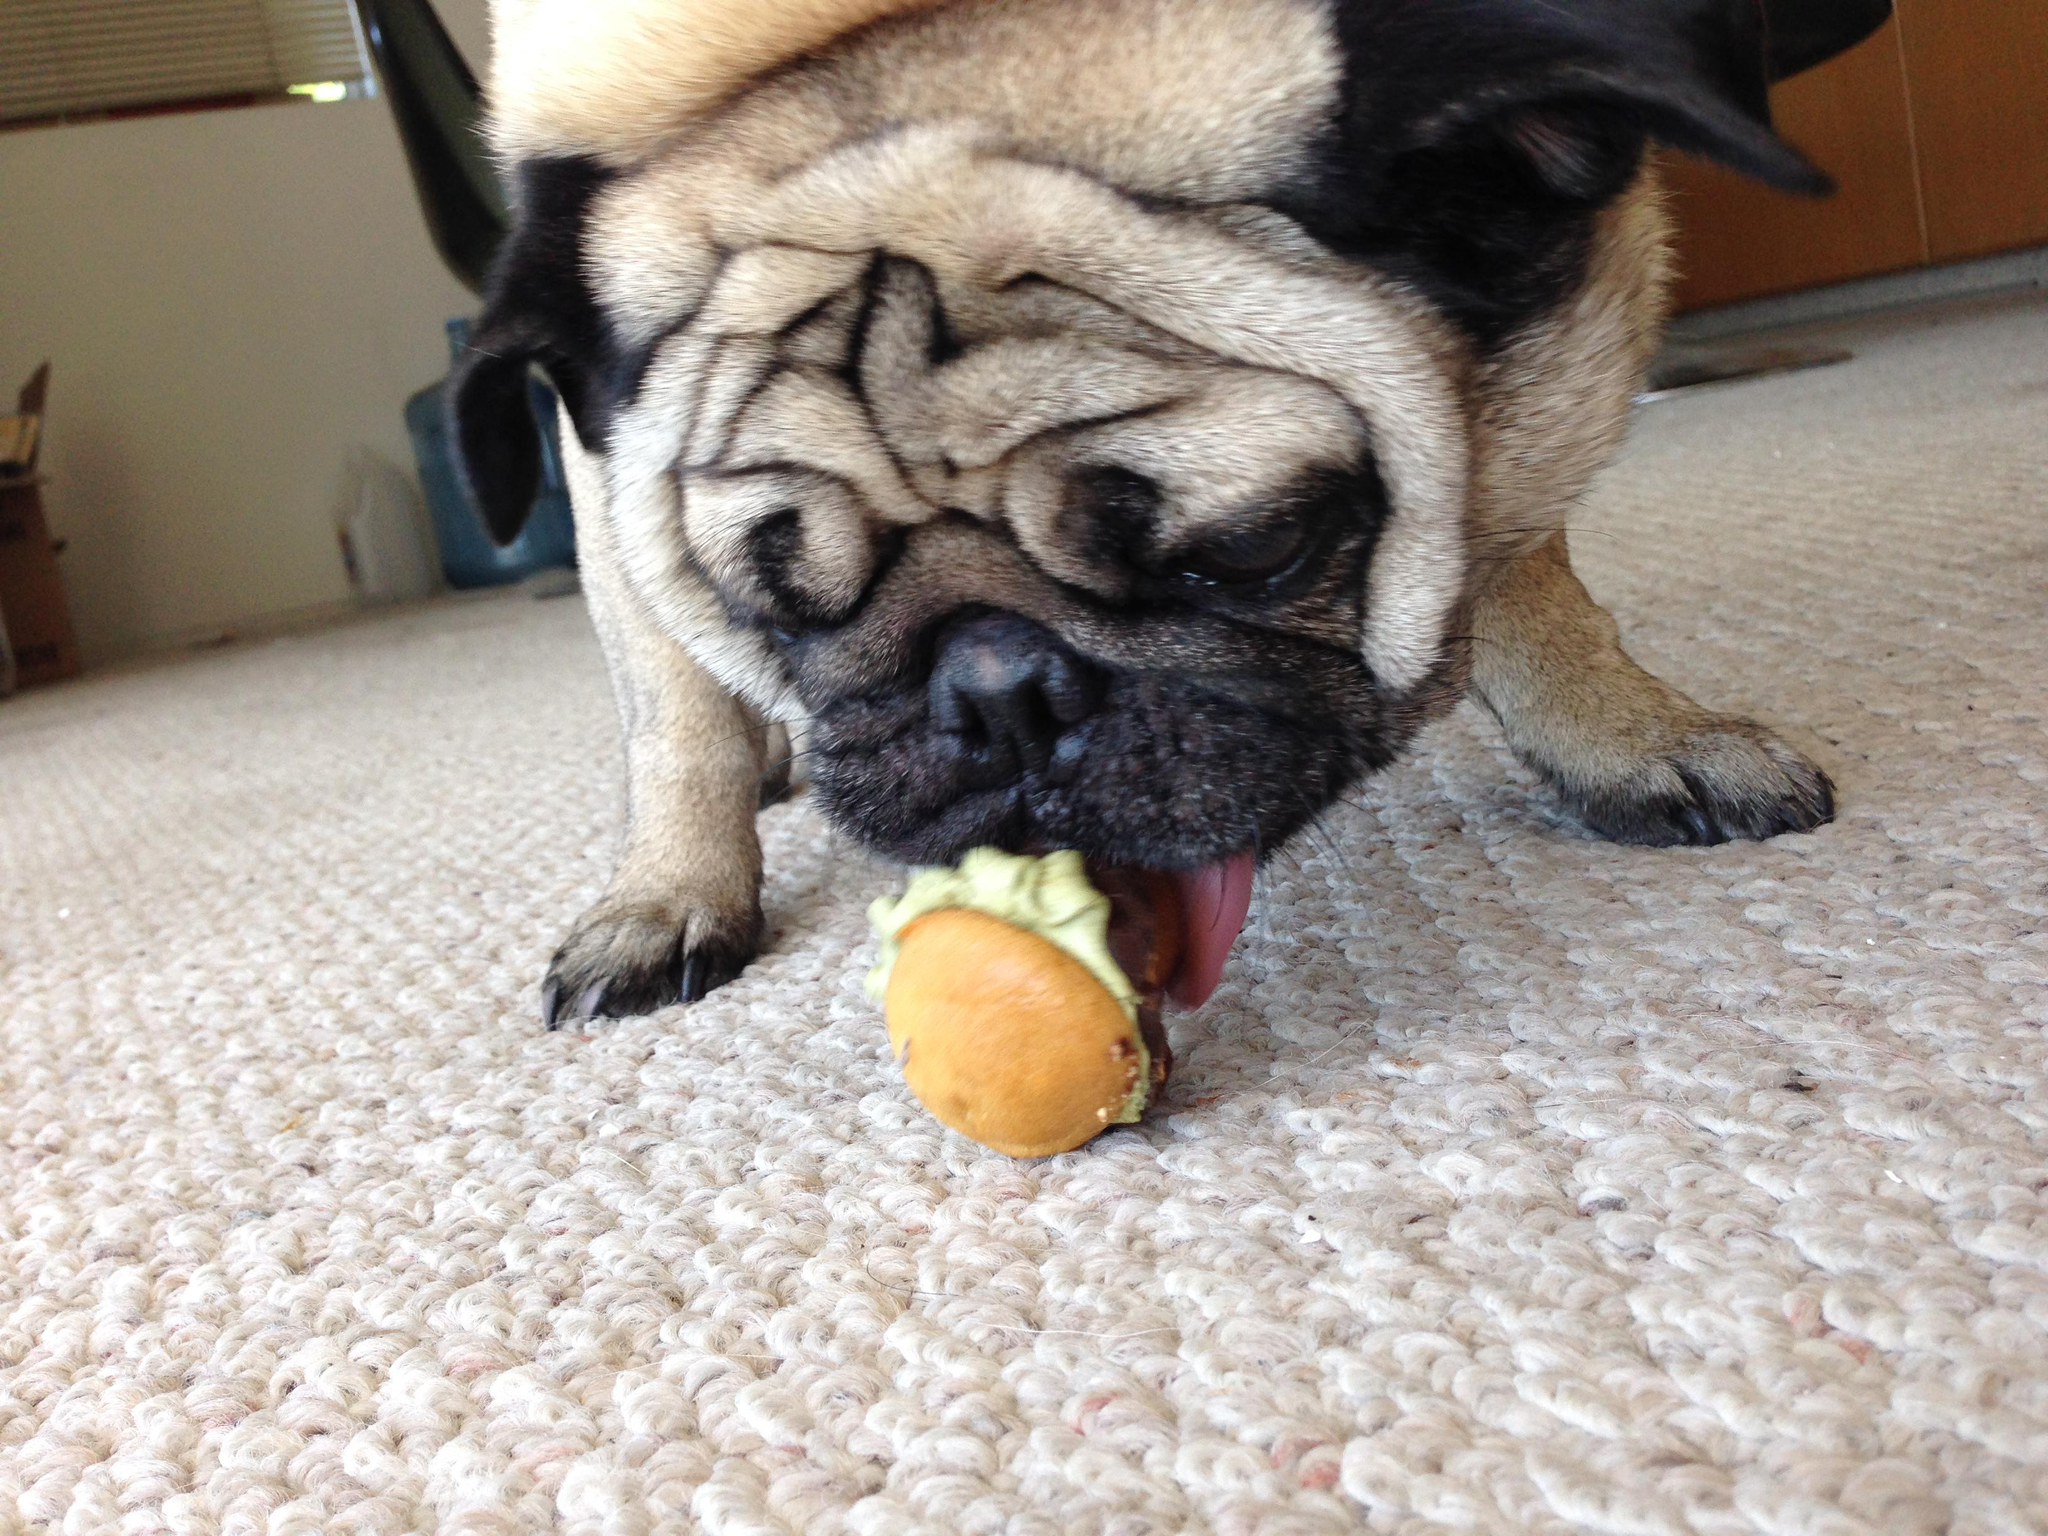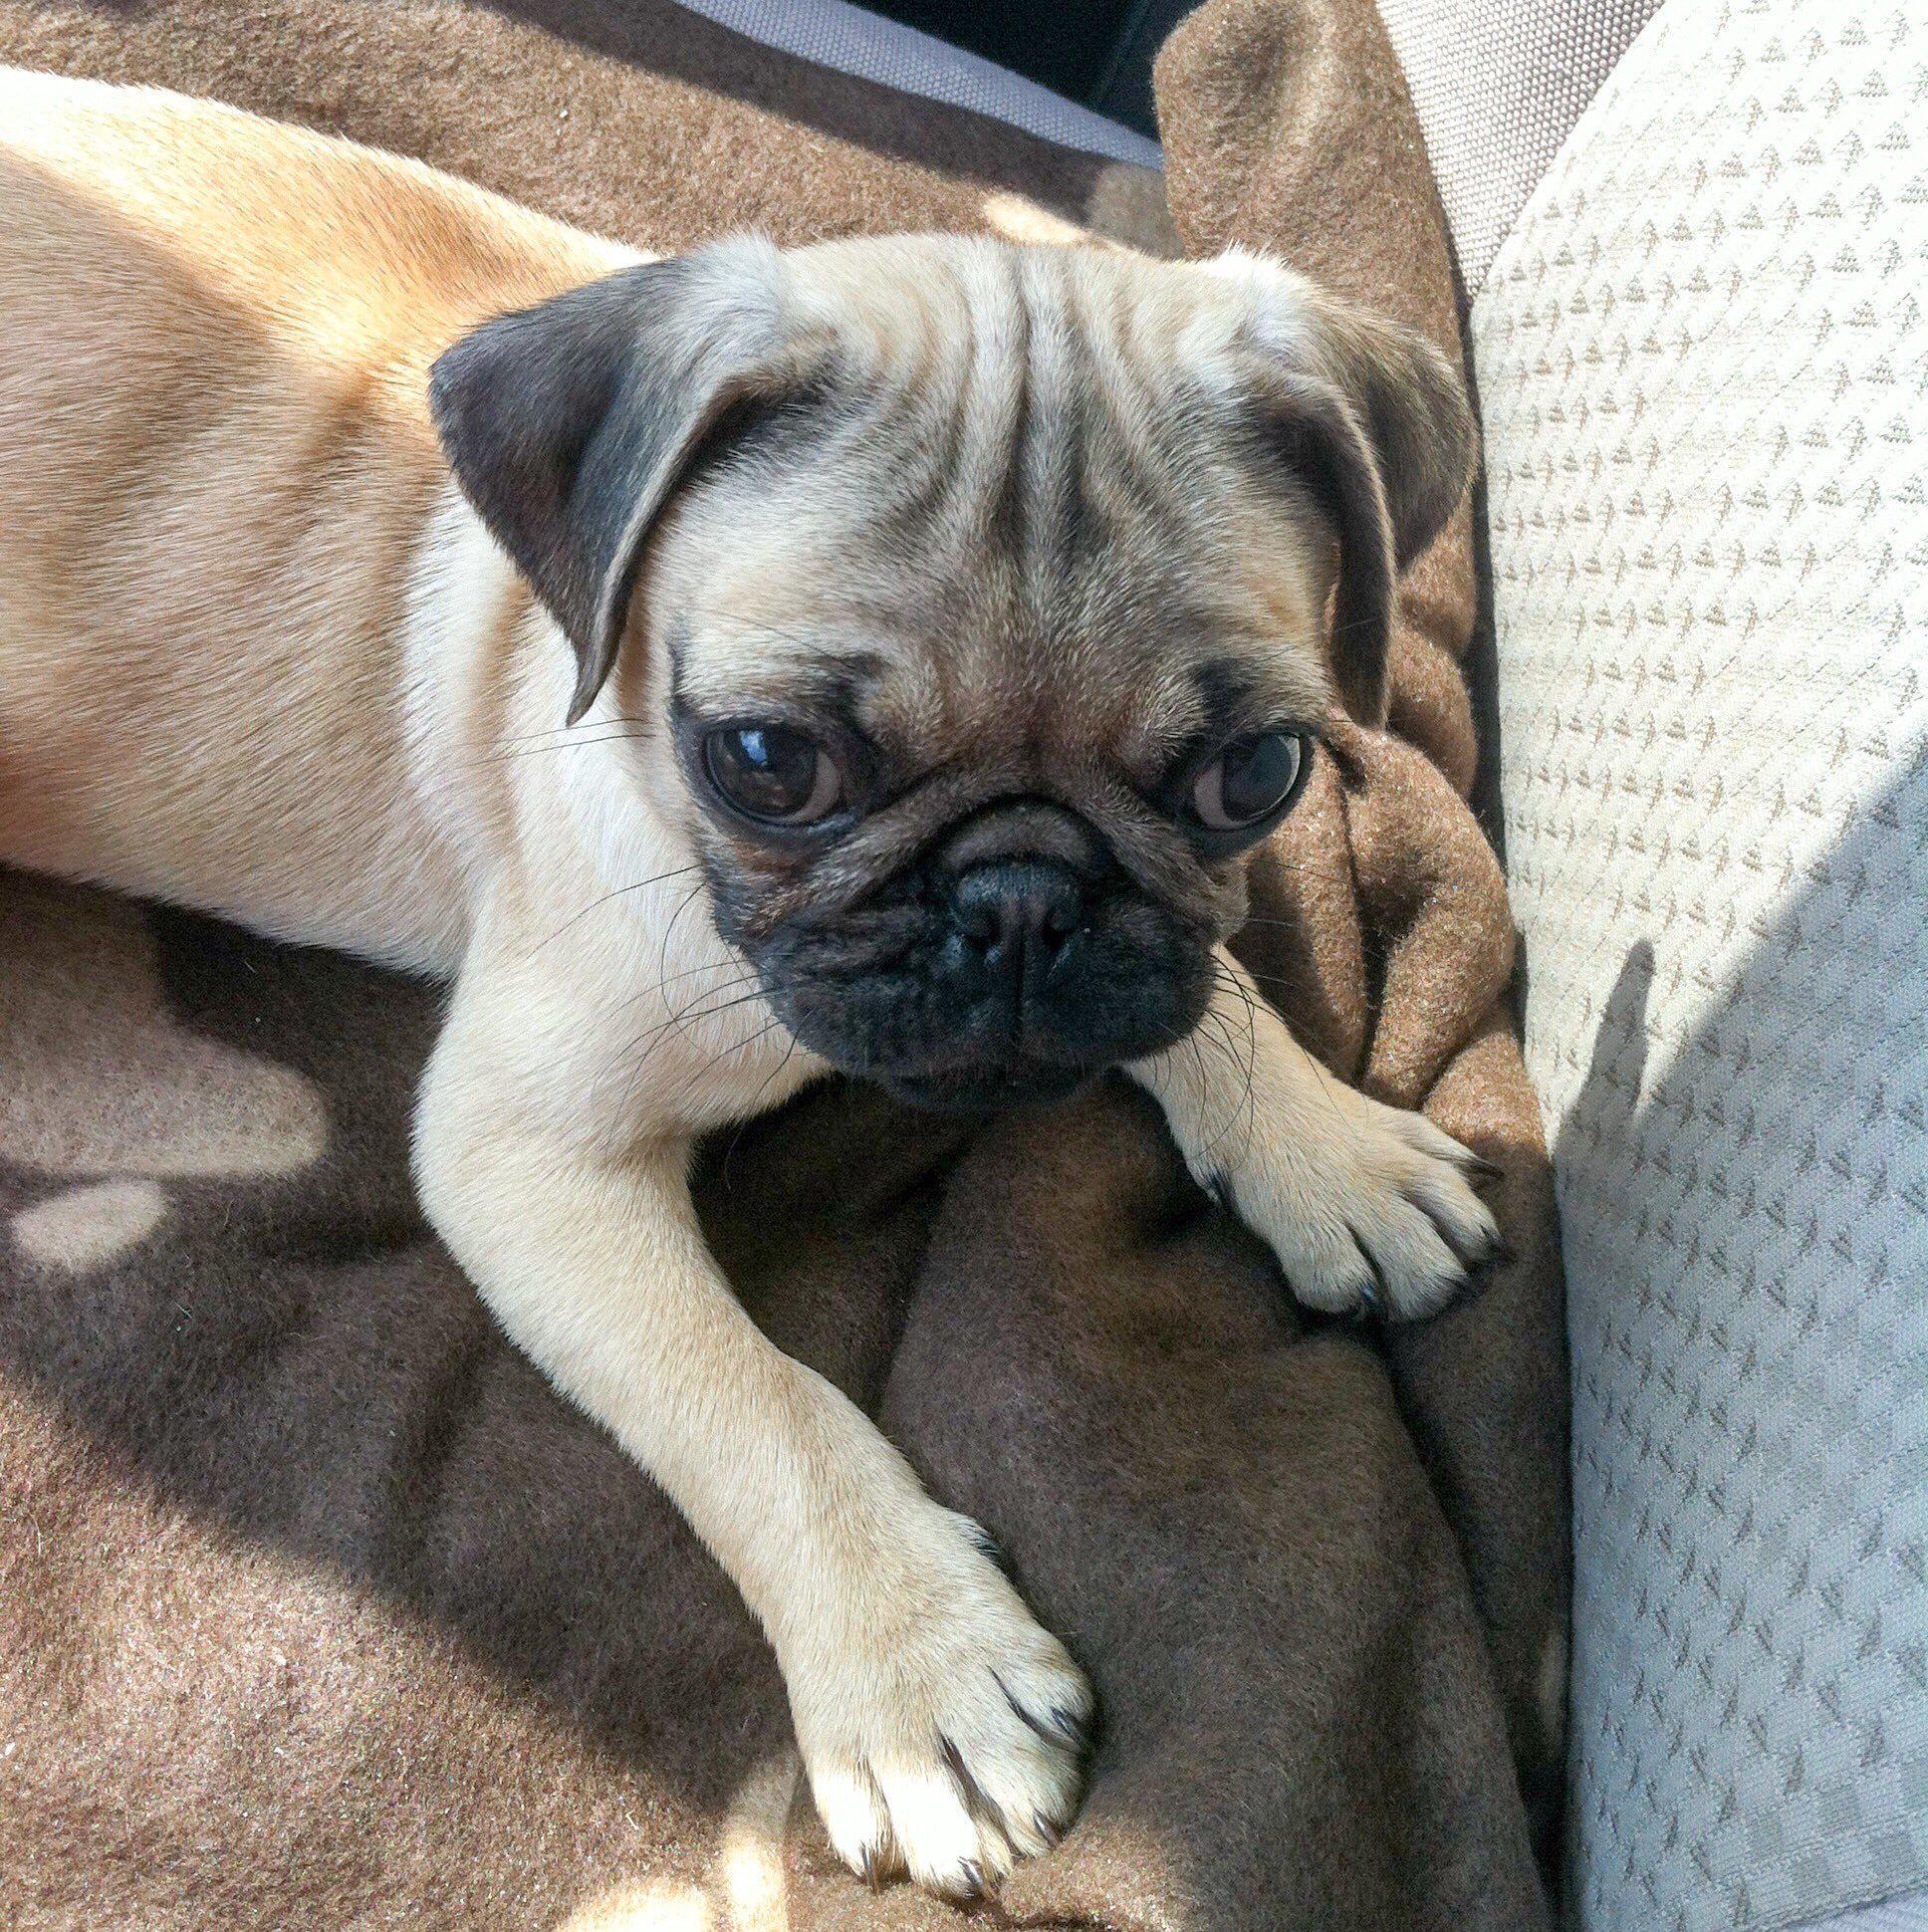The first image is the image on the left, the second image is the image on the right. Analyze the images presented: Is the assertion "There is a dog that is not eating anything." valid? Answer yes or no. Yes. The first image is the image on the left, the second image is the image on the right. Considering the images on both sides, is "At least 2 dogs are being fed ice cream in a waffle cone that a person is holding." valid? Answer yes or no. No. 